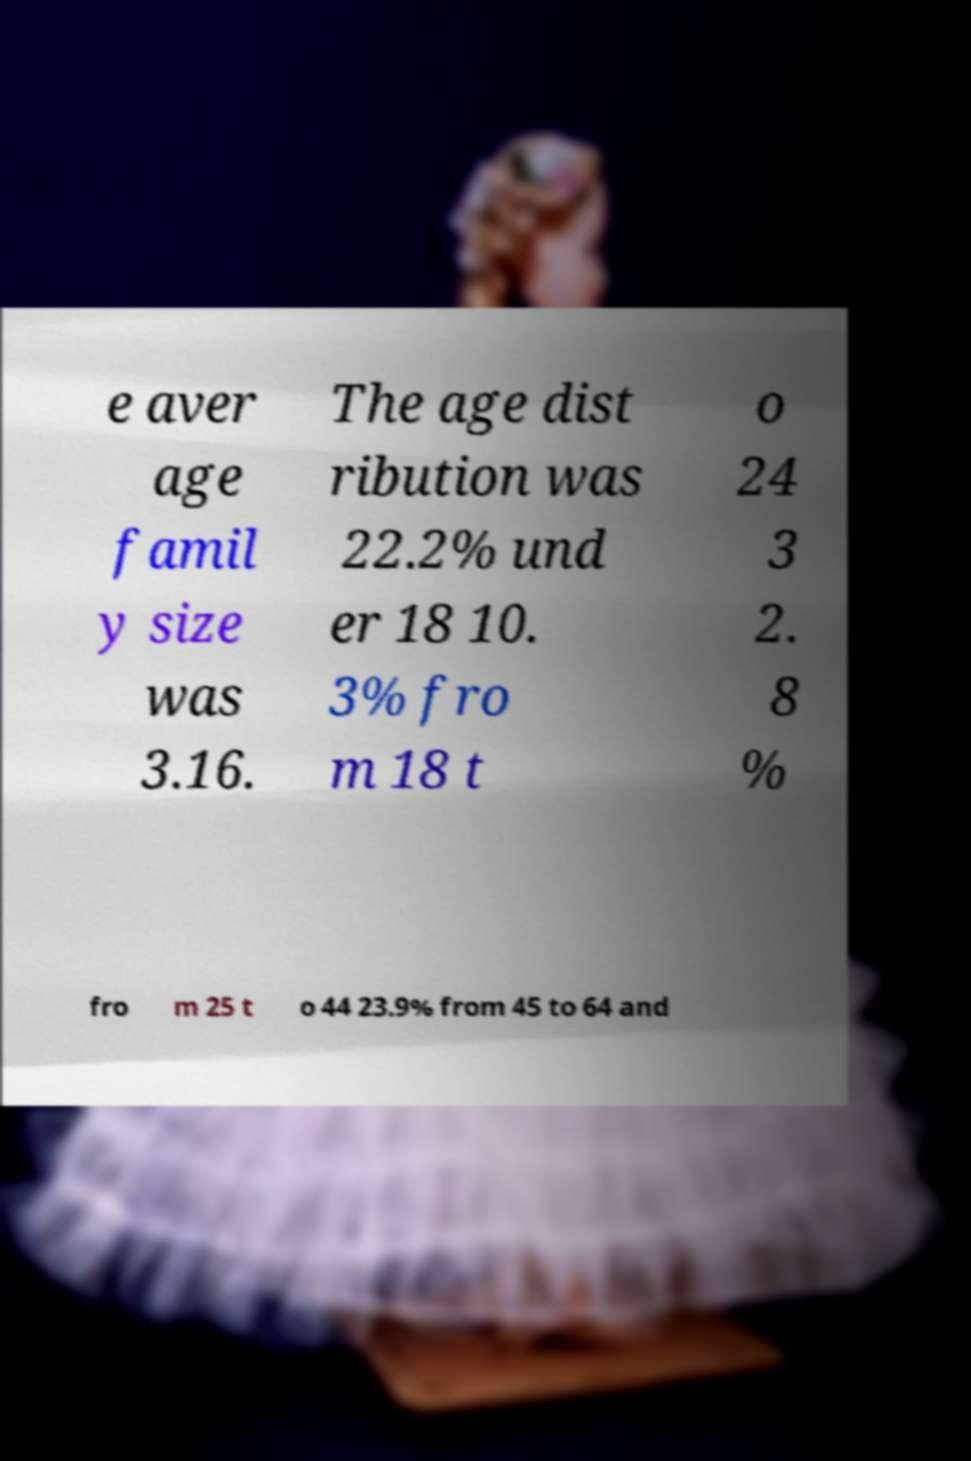Could you extract and type out the text from this image? e aver age famil y size was 3.16. The age dist ribution was 22.2% und er 18 10. 3% fro m 18 t o 24 3 2. 8 % fro m 25 t o 44 23.9% from 45 to 64 and 